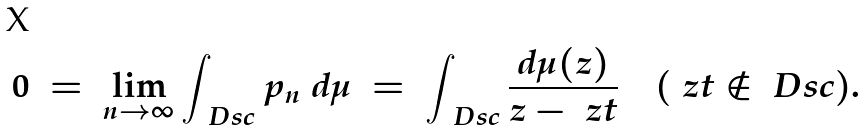Convert formula to latex. <formula><loc_0><loc_0><loc_500><loc_500>0 \ = \ \lim _ { n \to \infty } \int _ { \ D s c } p _ { n } \ d \mu \ = \ \int _ { \ D s c } \frac { d \mu ( z ) } { z - \ z t } \quad ( \ z t \notin \ D s c ) .</formula> 